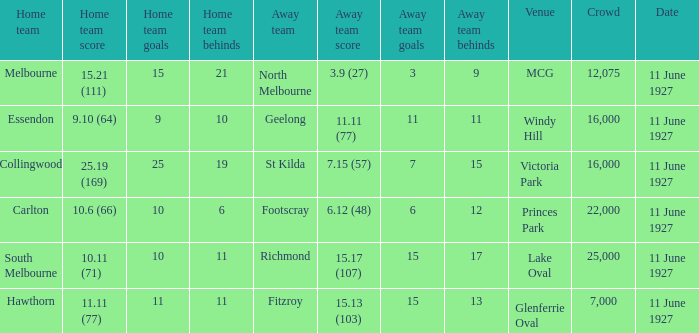What was the score for the home team of Essendon? 9.10 (64). 